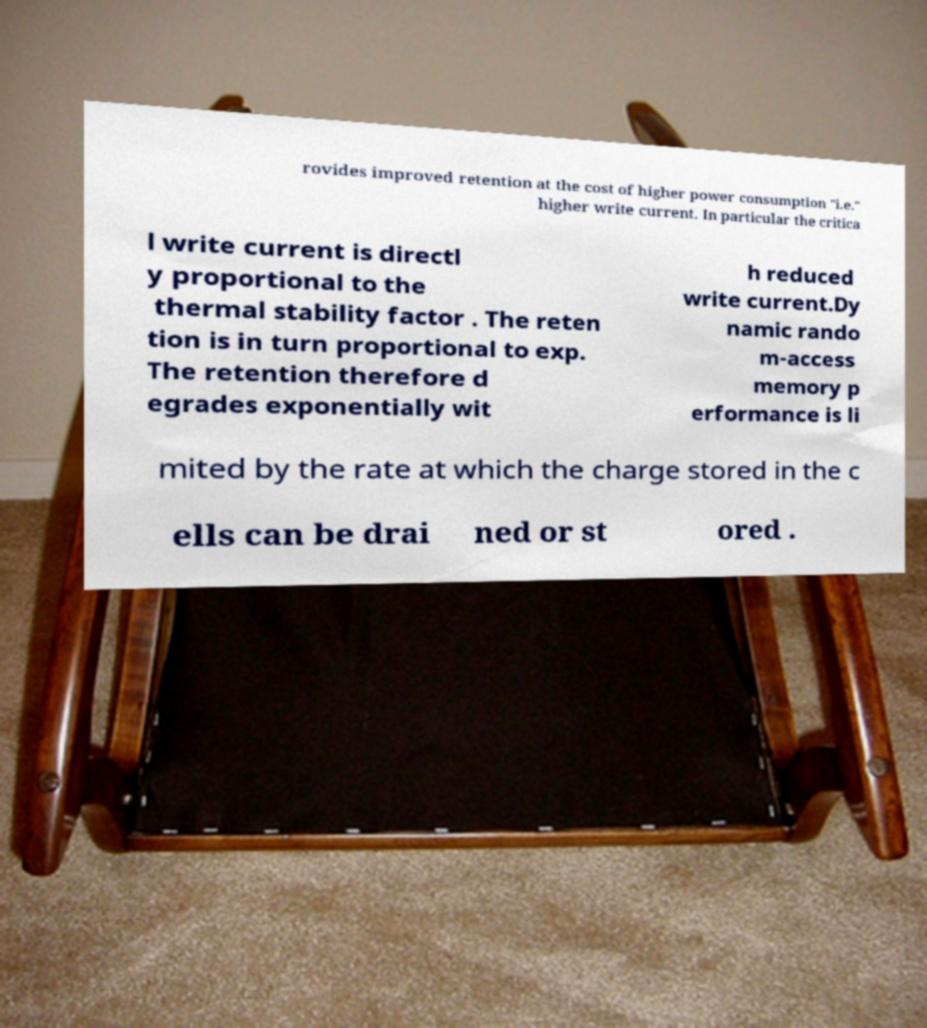Please identify and transcribe the text found in this image. rovides improved retention at the cost of higher power consumption "i.e." higher write current. In particular the critica l write current is directl y proportional to the thermal stability factor . The reten tion is in turn proportional to exp. The retention therefore d egrades exponentially wit h reduced write current.Dy namic rando m-access memory p erformance is li mited by the rate at which the charge stored in the c ells can be drai ned or st ored . 